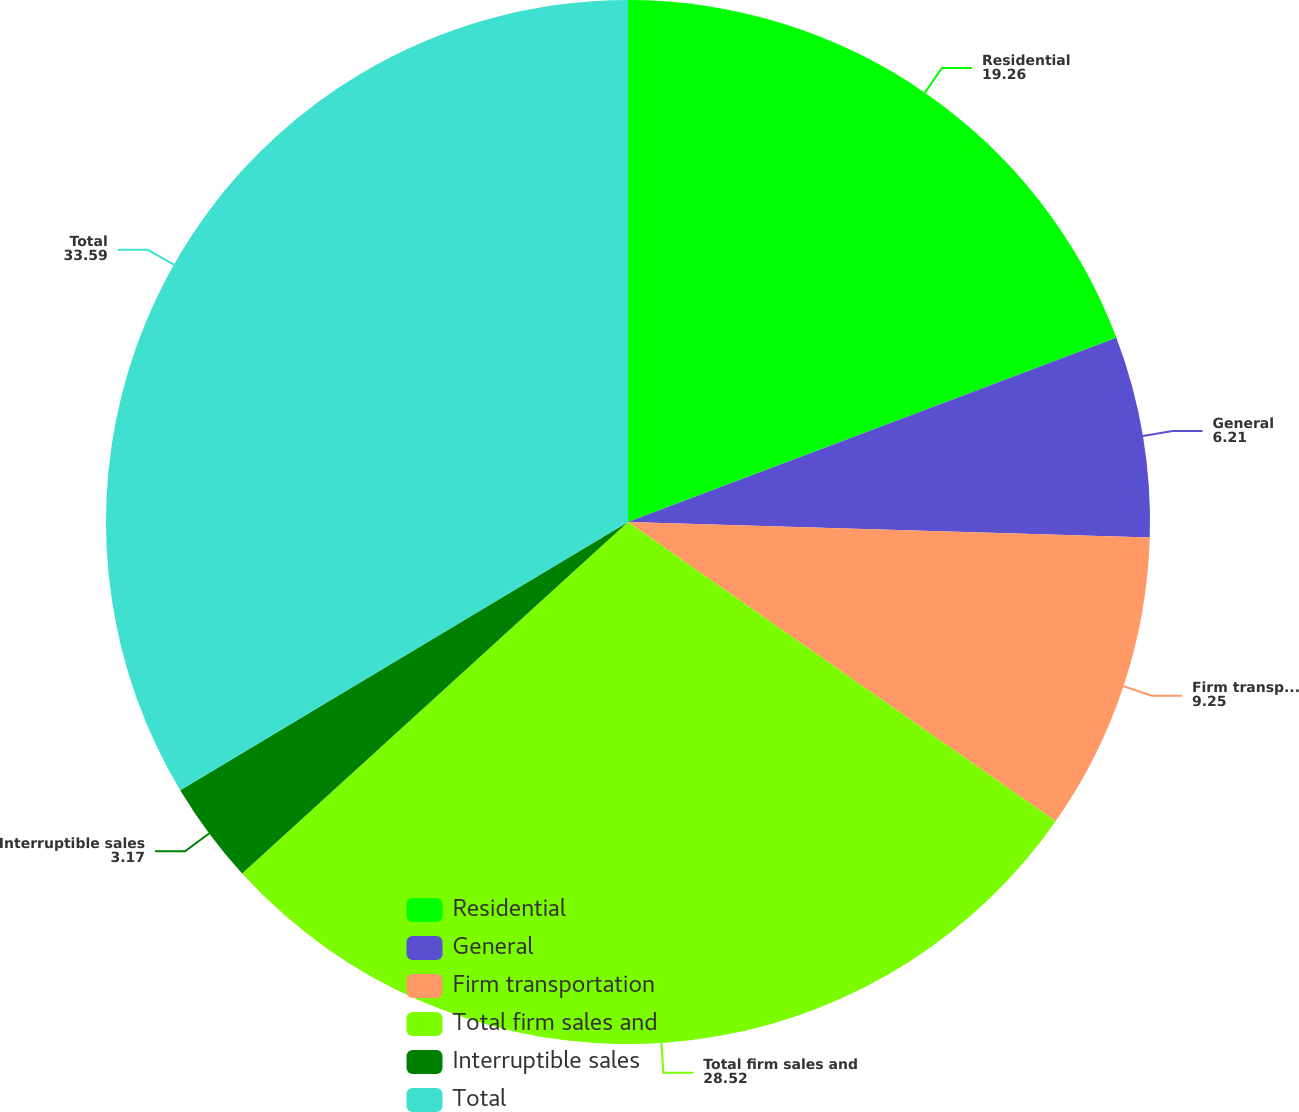<chart> <loc_0><loc_0><loc_500><loc_500><pie_chart><fcel>Residential<fcel>General<fcel>Firm transportation<fcel>Total firm sales and<fcel>Interruptible sales<fcel>Total<nl><fcel>19.26%<fcel>6.21%<fcel>9.25%<fcel>28.52%<fcel>3.17%<fcel>33.59%<nl></chart> 